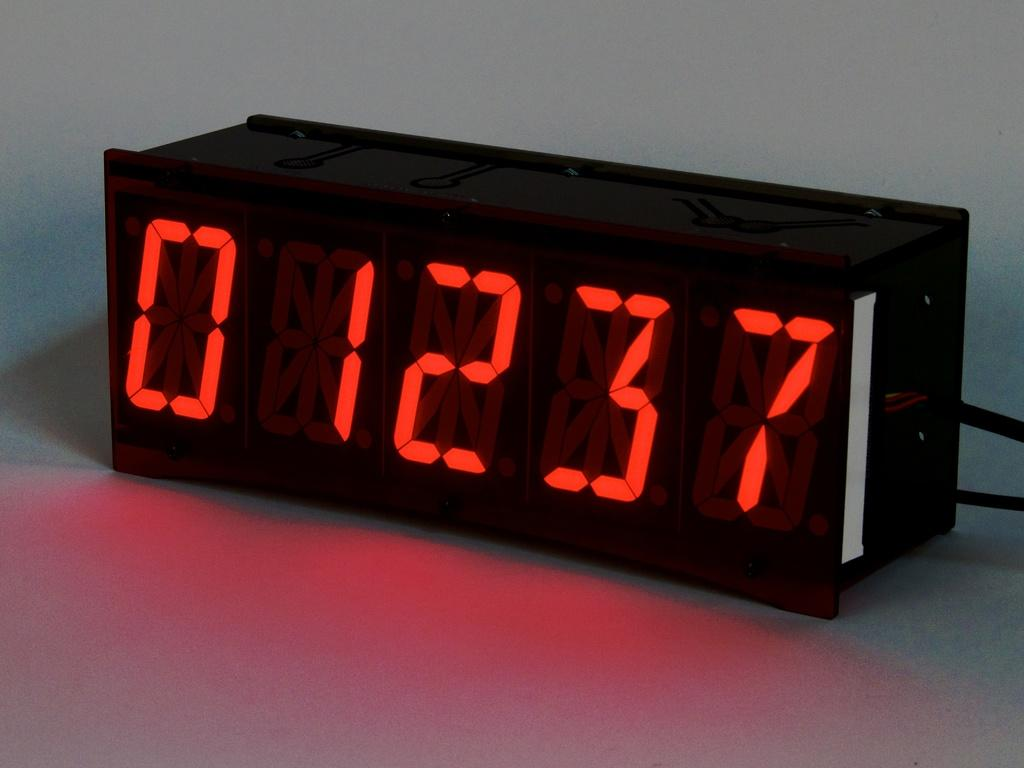<image>
Relay a brief, clear account of the picture shown. A black digital alarm clock reads 12:37 in red letters. 